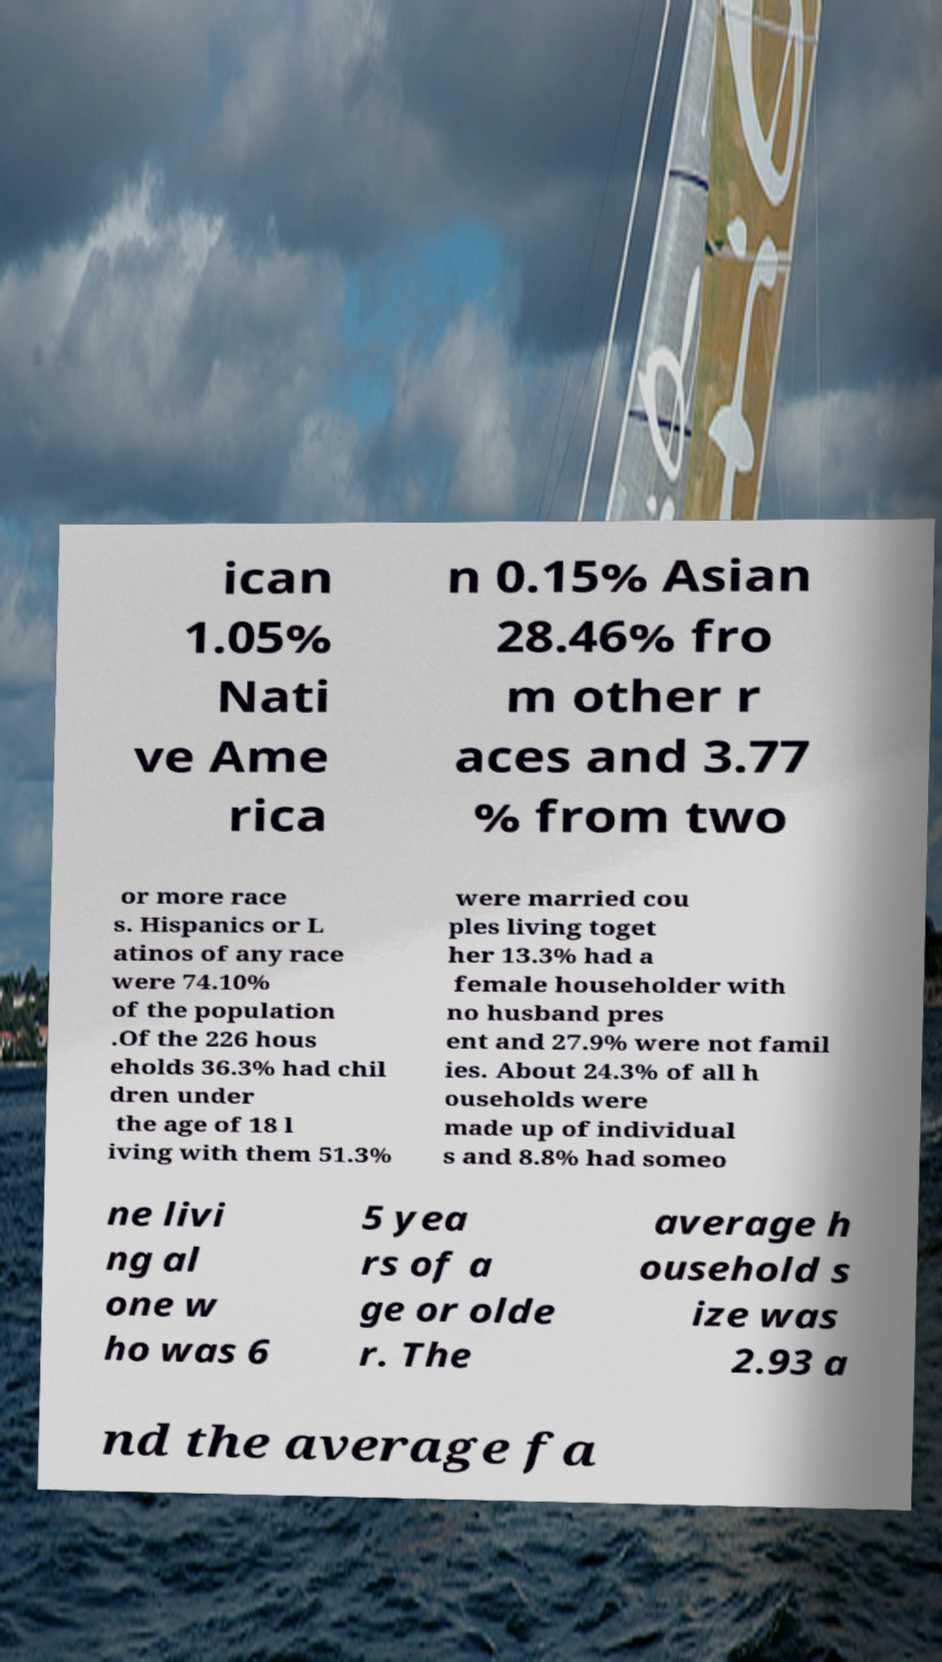Please read and relay the text visible in this image. What does it say? ican 1.05% Nati ve Ame rica n 0.15% Asian 28.46% fro m other r aces and 3.77 % from two or more race s. Hispanics or L atinos of any race were 74.10% of the population .Of the 226 hous eholds 36.3% had chil dren under the age of 18 l iving with them 51.3% were married cou ples living toget her 13.3% had a female householder with no husband pres ent and 27.9% were not famil ies. About 24.3% of all h ouseholds were made up of individual s and 8.8% had someo ne livi ng al one w ho was 6 5 yea rs of a ge or olde r. The average h ousehold s ize was 2.93 a nd the average fa 